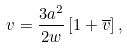Convert formula to latex. <formula><loc_0><loc_0><loc_500><loc_500>v = { \frac { 3 a ^ { 2 } } { 2 w } } \left [ 1 + \overline { v } \right ] ,</formula> 